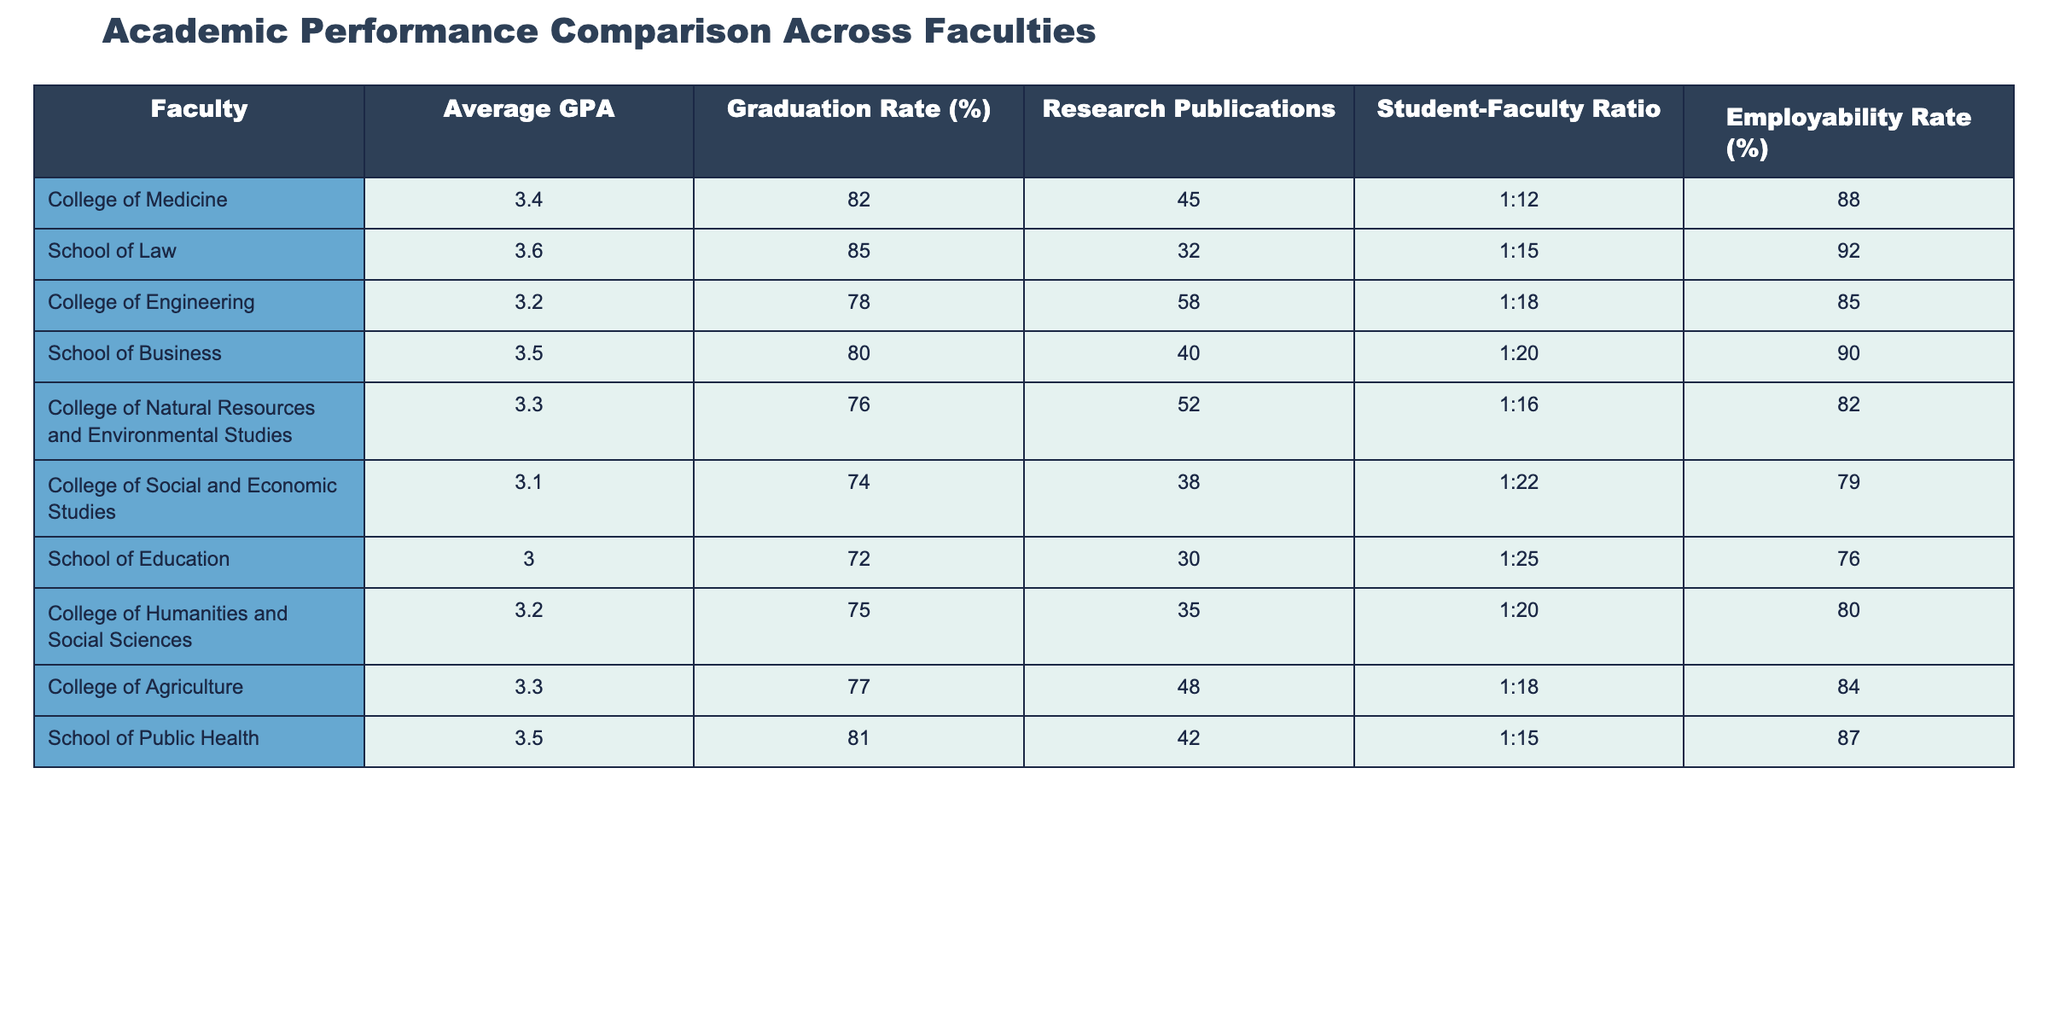What is the average GPA for the College of Medicine? The table shows that the average GPA for the College of Medicine is listed directly as 3.4.
Answer: 3.4 Which faculty has the highest graduation rate? By comparing the graduation rates across all faculties, the School of Law has the highest graduation rate at 85%.
Answer: School of Law What is the employability rate for the College of Social and Economic Studies? The table indicates that the employability rate for the College of Social and Economic Studies is 79%.
Answer: 79 Calculate the difference in research publications between the College of Engineering and the College of Agriculture. The College of Engineering has 58 research publications, and the College of Agriculture has 48. The difference is 58 - 48 = 10.
Answer: 10 True or False: The School of Education has a higher employability rate than the College of Humanities and Social Sciences. The employability rate for the School of Education is 76%, and for the College of Humanities and Social Sciences, it is 80%. Since 76% is not greater than 80%, the statement is false.
Answer: False What is the average graduation rate for the faculties that have an average GPA higher than 3.3? The faculties with an average GPA higher than 3.3 are the School of Law (85%), School of Business (80%), and School of Public Health (81%). To find the average, add the three rates: 85 + 80 + 81 = 246, then divide by 3, resulting in 246 / 3 = 82.
Answer: 82 Which faculty has the best student-faculty ratio? Looking at the student-faculty ratios, the College of Medicine has the best ratio of 1:12, which is lower compared to the ratios of other faculties.
Answer: College of Medicine How many faculties have an average GPA below 3.3? The faculties with an average GPA below 3.3 are the College of Social and Economic Studies (3.1), School of Education (3.0), and the College of Engineering (3.2). That totals three faculties.
Answer: 3 What is the overall average GPA of all faculties? To find the overall average GPA, sum all the average GPAs: 3.4 + 3.6 + 3.2 + 3.5 + 3.3 + 3.1 + 3.0 + 3.2 + 3.3 + 3.5 = 32.1. Then divide by the total number of faculties (10), which gives us 32.1 / 10 = 3.21.
Answer: 3.21 